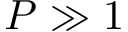<formula> <loc_0><loc_0><loc_500><loc_500>P \gg 1</formula> 